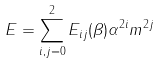Convert formula to latex. <formula><loc_0><loc_0><loc_500><loc_500>E = \sum _ { i , j = 0 } ^ { 2 } E _ { i j } ( \beta ) \alpha ^ { 2 i } m ^ { 2 j }</formula> 